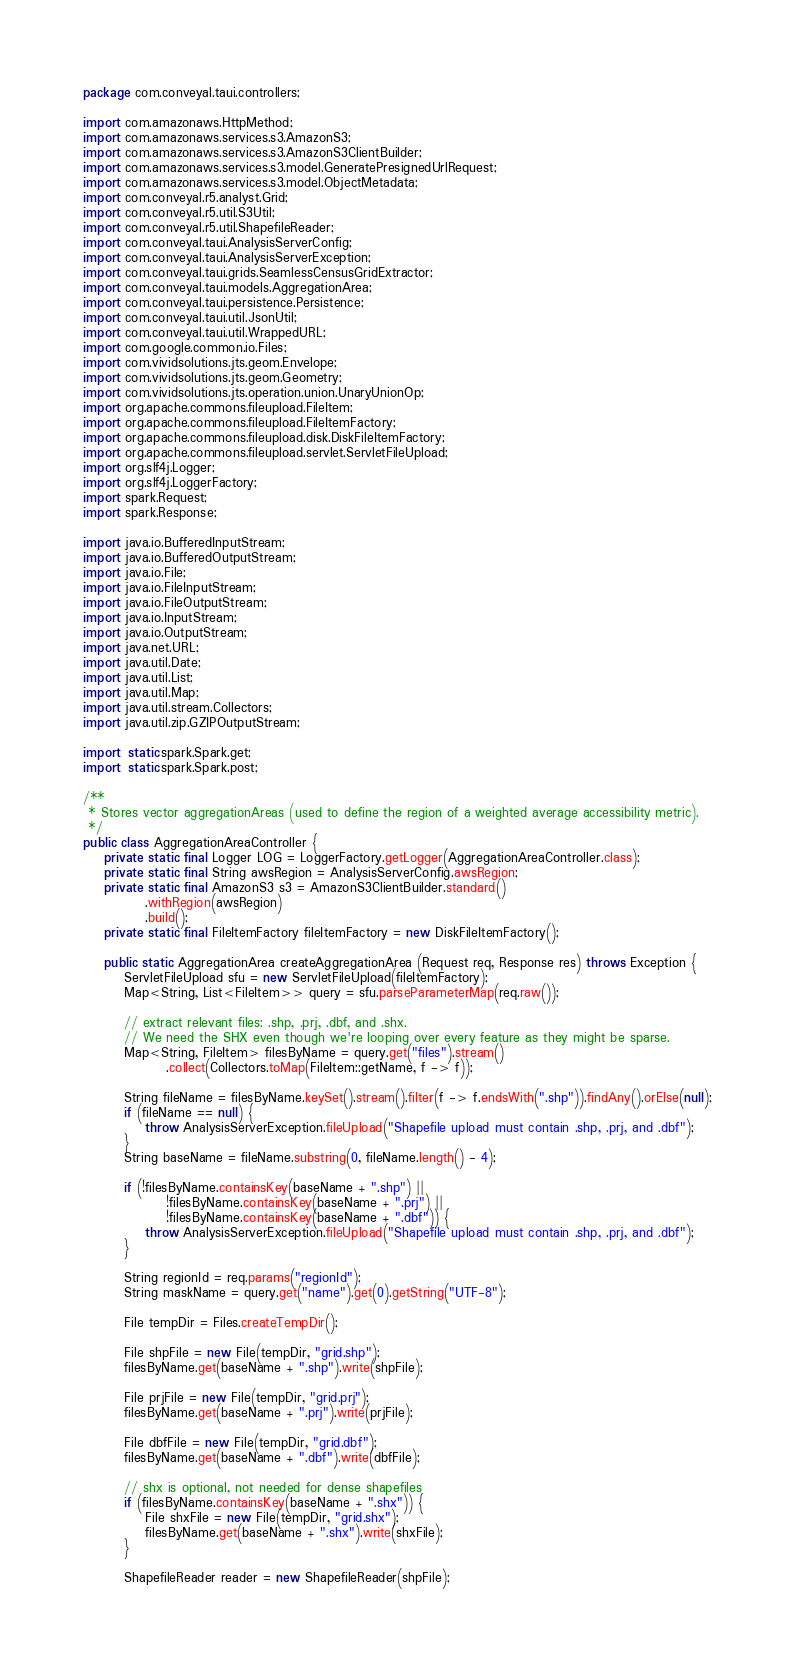Convert code to text. <code><loc_0><loc_0><loc_500><loc_500><_Java_>package com.conveyal.taui.controllers;

import com.amazonaws.HttpMethod;
import com.amazonaws.services.s3.AmazonS3;
import com.amazonaws.services.s3.AmazonS3ClientBuilder;
import com.amazonaws.services.s3.model.GeneratePresignedUrlRequest;
import com.amazonaws.services.s3.model.ObjectMetadata;
import com.conveyal.r5.analyst.Grid;
import com.conveyal.r5.util.S3Util;
import com.conveyal.r5.util.ShapefileReader;
import com.conveyal.taui.AnalysisServerConfig;
import com.conveyal.taui.AnalysisServerException;
import com.conveyal.taui.grids.SeamlessCensusGridExtractor;
import com.conveyal.taui.models.AggregationArea;
import com.conveyal.taui.persistence.Persistence;
import com.conveyal.taui.util.JsonUtil;
import com.conveyal.taui.util.WrappedURL;
import com.google.common.io.Files;
import com.vividsolutions.jts.geom.Envelope;
import com.vividsolutions.jts.geom.Geometry;
import com.vividsolutions.jts.operation.union.UnaryUnionOp;
import org.apache.commons.fileupload.FileItem;
import org.apache.commons.fileupload.FileItemFactory;
import org.apache.commons.fileupload.disk.DiskFileItemFactory;
import org.apache.commons.fileupload.servlet.ServletFileUpload;
import org.slf4j.Logger;
import org.slf4j.LoggerFactory;
import spark.Request;
import spark.Response;

import java.io.BufferedInputStream;
import java.io.BufferedOutputStream;
import java.io.File;
import java.io.FileInputStream;
import java.io.FileOutputStream;
import java.io.InputStream;
import java.io.OutputStream;
import java.net.URL;
import java.util.Date;
import java.util.List;
import java.util.Map;
import java.util.stream.Collectors;
import java.util.zip.GZIPOutputStream;

import static spark.Spark.get;
import static spark.Spark.post;

/**
 * Stores vector aggregationAreas (used to define the region of a weighted average accessibility metric).
 */
public class AggregationAreaController {
    private static final Logger LOG = LoggerFactory.getLogger(AggregationAreaController.class);
    private static final String awsRegion = AnalysisServerConfig.awsRegion;
    private static final AmazonS3 s3 = AmazonS3ClientBuilder.standard()
            .withRegion(awsRegion)
            .build();
    private static final FileItemFactory fileItemFactory = new DiskFileItemFactory();

    public static AggregationArea createAggregationArea (Request req, Response res) throws Exception {
        ServletFileUpload sfu = new ServletFileUpload(fileItemFactory);
        Map<String, List<FileItem>> query = sfu.parseParameterMap(req.raw());

        // extract relevant files: .shp, .prj, .dbf, and .shx.
        // We need the SHX even though we're looping over every feature as they might be sparse.
        Map<String, FileItem> filesByName = query.get("files").stream()
                .collect(Collectors.toMap(FileItem::getName, f -> f));

        String fileName = filesByName.keySet().stream().filter(f -> f.endsWith(".shp")).findAny().orElse(null);
        if (fileName == null) {
            throw AnalysisServerException.fileUpload("Shapefile upload must contain .shp, .prj, and .dbf");
        }
        String baseName = fileName.substring(0, fileName.length() - 4);

        if (!filesByName.containsKey(baseName + ".shp") ||
                !filesByName.containsKey(baseName + ".prj") ||
                !filesByName.containsKey(baseName + ".dbf")) {
            throw AnalysisServerException.fileUpload("Shapefile upload must contain .shp, .prj, and .dbf");
        }

        String regionId = req.params("regionId");
        String maskName = query.get("name").get(0).getString("UTF-8");

        File tempDir = Files.createTempDir();

        File shpFile = new File(tempDir, "grid.shp");
        filesByName.get(baseName + ".shp").write(shpFile);

        File prjFile = new File(tempDir, "grid.prj");
        filesByName.get(baseName + ".prj").write(prjFile);

        File dbfFile = new File(tempDir, "grid.dbf");
        filesByName.get(baseName + ".dbf").write(dbfFile);

        // shx is optional, not needed for dense shapefiles
        if (filesByName.containsKey(baseName + ".shx")) {
            File shxFile = new File(tempDir, "grid.shx");
            filesByName.get(baseName + ".shx").write(shxFile);
        }

        ShapefileReader reader = new ShapefileReader(shpFile);
</code> 